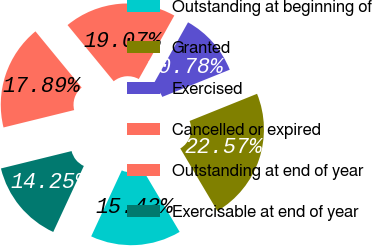<chart> <loc_0><loc_0><loc_500><loc_500><pie_chart><fcel>Outstanding at beginning of<fcel>Granted<fcel>Exercised<fcel>Cancelled or expired<fcel>Outstanding at end of year<fcel>Exercisable at end of year<nl><fcel>15.43%<fcel>22.57%<fcel>10.78%<fcel>19.07%<fcel>17.89%<fcel>14.25%<nl></chart> 